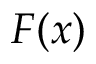Convert formula to latex. <formula><loc_0><loc_0><loc_500><loc_500>F ( x )</formula> 